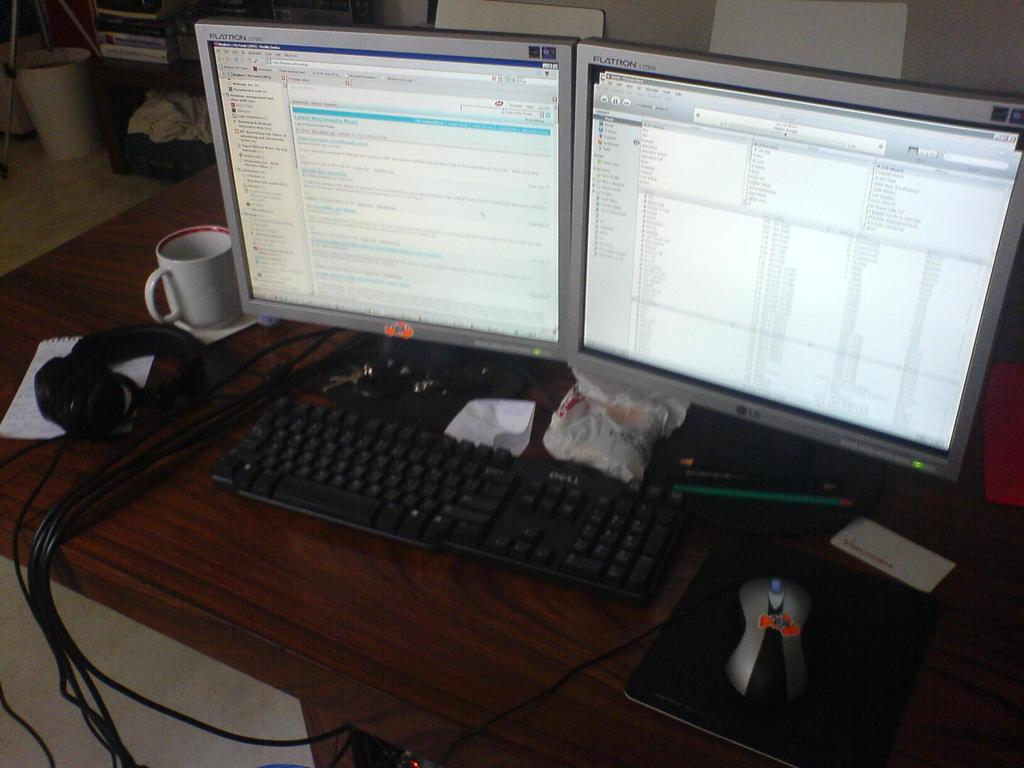<image>
Offer a succinct explanation of the picture presented. Dell keyboard next to two computer monitors on a table. 